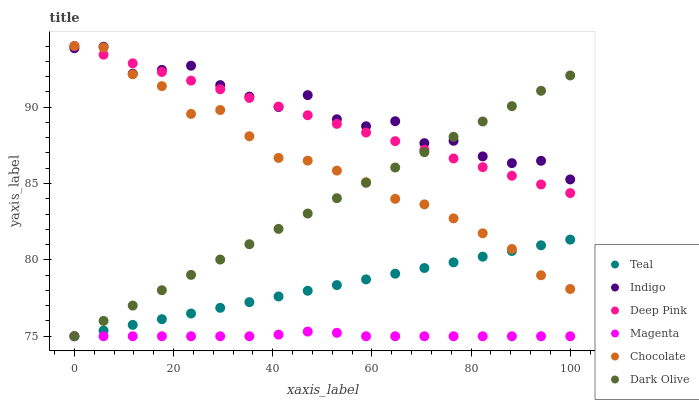Does Magenta have the minimum area under the curve?
Answer yes or no. Yes. Does Indigo have the maximum area under the curve?
Answer yes or no. Yes. Does Dark Olive have the minimum area under the curve?
Answer yes or no. No. Does Dark Olive have the maximum area under the curve?
Answer yes or no. No. Is Dark Olive the smoothest?
Answer yes or no. Yes. Is Indigo the roughest?
Answer yes or no. Yes. Is Indigo the smoothest?
Answer yes or no. No. Is Dark Olive the roughest?
Answer yes or no. No. Does Dark Olive have the lowest value?
Answer yes or no. Yes. Does Indigo have the lowest value?
Answer yes or no. No. Does Chocolate have the highest value?
Answer yes or no. Yes. Does Indigo have the highest value?
Answer yes or no. No. Is Magenta less than Deep Pink?
Answer yes or no. Yes. Is Chocolate greater than Magenta?
Answer yes or no. Yes. Does Teal intersect Magenta?
Answer yes or no. Yes. Is Teal less than Magenta?
Answer yes or no. No. Is Teal greater than Magenta?
Answer yes or no. No. Does Magenta intersect Deep Pink?
Answer yes or no. No. 